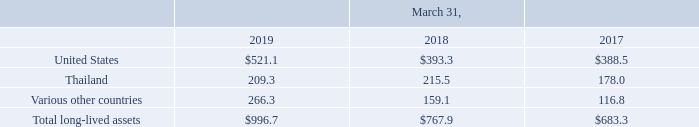The following table summarizes our long-lived assets (consisting of property, plant and equipment) by geography at the end of fiscal 2019, fiscal 2018 and fiscal 2017 (in millions).
We have many suppliers of raw materials and subcontractors which provide our various materials and service needs. We generally seek to have multiple sources of supply for our raw materials and services, but, in some cases, we may rely on a single or limited number of suppliers.
Which years does the table provide data for the company's long-lived assets? 2019, 2018, 2017. What was the amount of assets in United States in 2019?
Answer scale should be: million. 521.1. What was the amount of total long-lived assets in 2017?
Answer scale should be: million. 683.3. Which years did assets from Thailand exceed $200 million? (2019:209.3),(2018:215.5)
Answer: 2019, 2018. What was the change in assets from various other countries between 2017 and 2018?
Answer scale should be: million. 159.1-116.8
Answer: 42.3. What was the percentage change in the total long-lived assets between 2018 and 2019?
Answer scale should be: percent. (996.7-767.9)/767.9
Answer: 29.8. 